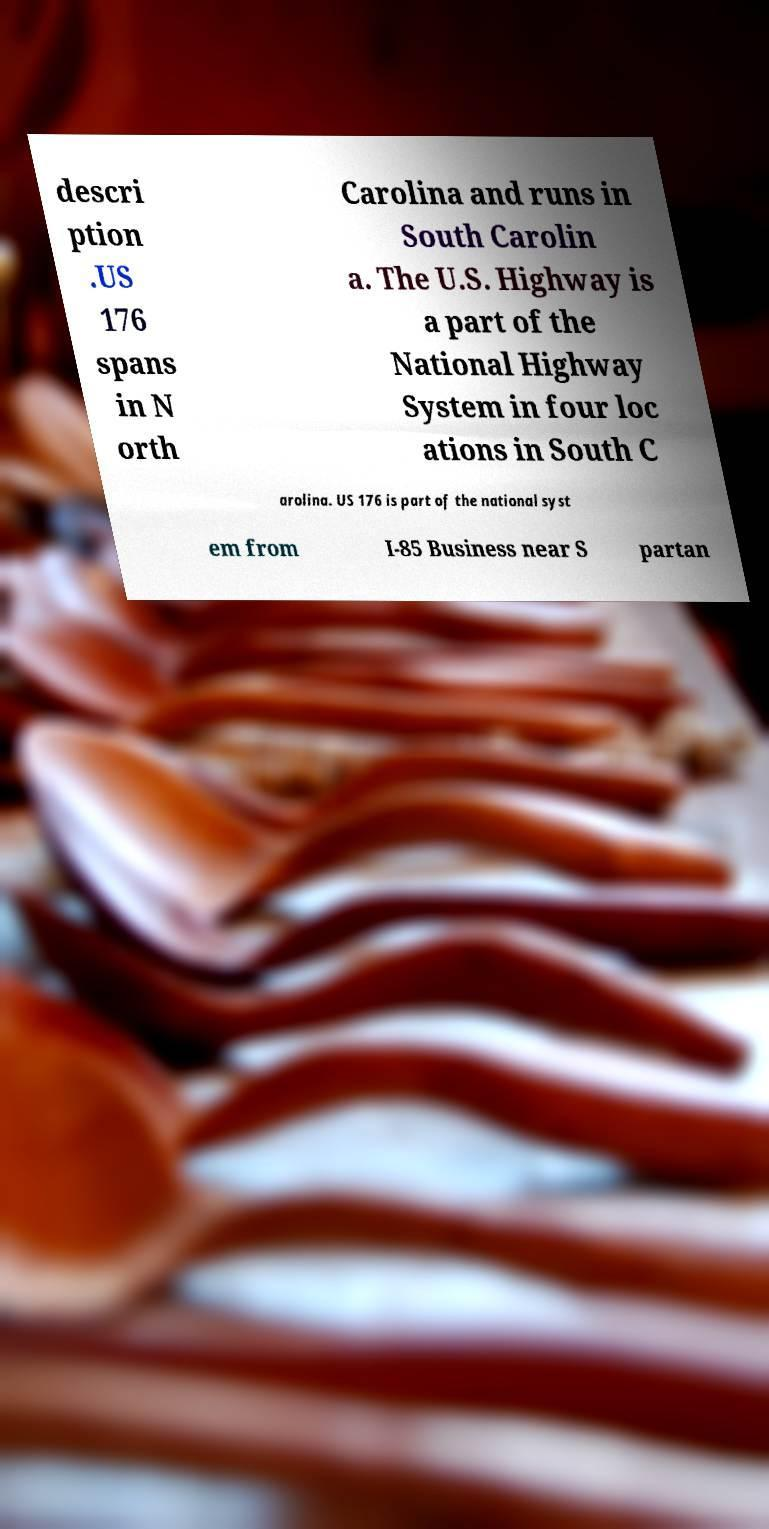Can you read and provide the text displayed in the image?This photo seems to have some interesting text. Can you extract and type it out for me? descri ption .US 176 spans in N orth Carolina and runs in South Carolin a. The U.S. Highway is a part of the National Highway System in four loc ations in South C arolina. US 176 is part of the national syst em from I-85 Business near S partan 